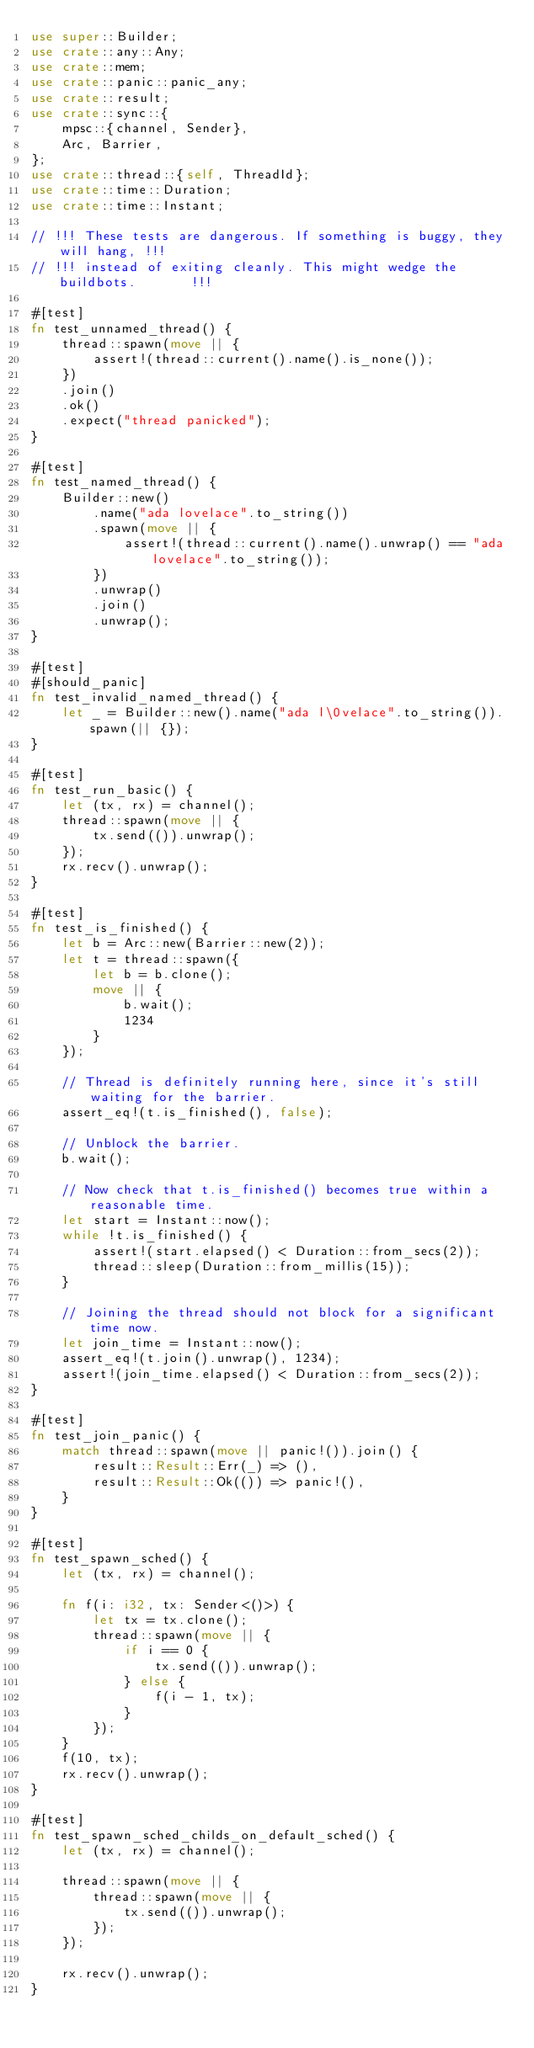Convert code to text. <code><loc_0><loc_0><loc_500><loc_500><_Rust_>use super::Builder;
use crate::any::Any;
use crate::mem;
use crate::panic::panic_any;
use crate::result;
use crate::sync::{
    mpsc::{channel, Sender},
    Arc, Barrier,
};
use crate::thread::{self, ThreadId};
use crate::time::Duration;
use crate::time::Instant;

// !!! These tests are dangerous. If something is buggy, they will hang, !!!
// !!! instead of exiting cleanly. This might wedge the buildbots.       !!!

#[test]
fn test_unnamed_thread() {
    thread::spawn(move || {
        assert!(thread::current().name().is_none());
    })
    .join()
    .ok()
    .expect("thread panicked");
}

#[test]
fn test_named_thread() {
    Builder::new()
        .name("ada lovelace".to_string())
        .spawn(move || {
            assert!(thread::current().name().unwrap() == "ada lovelace".to_string());
        })
        .unwrap()
        .join()
        .unwrap();
}

#[test]
#[should_panic]
fn test_invalid_named_thread() {
    let _ = Builder::new().name("ada l\0velace".to_string()).spawn(|| {});
}

#[test]
fn test_run_basic() {
    let (tx, rx) = channel();
    thread::spawn(move || {
        tx.send(()).unwrap();
    });
    rx.recv().unwrap();
}

#[test]
fn test_is_finished() {
    let b = Arc::new(Barrier::new(2));
    let t = thread::spawn({
        let b = b.clone();
        move || {
            b.wait();
            1234
        }
    });

    // Thread is definitely running here, since it's still waiting for the barrier.
    assert_eq!(t.is_finished(), false);

    // Unblock the barrier.
    b.wait();

    // Now check that t.is_finished() becomes true within a reasonable time.
    let start = Instant::now();
    while !t.is_finished() {
        assert!(start.elapsed() < Duration::from_secs(2));
        thread::sleep(Duration::from_millis(15));
    }

    // Joining the thread should not block for a significant time now.
    let join_time = Instant::now();
    assert_eq!(t.join().unwrap(), 1234);
    assert!(join_time.elapsed() < Duration::from_secs(2));
}

#[test]
fn test_join_panic() {
    match thread::spawn(move || panic!()).join() {
        result::Result::Err(_) => (),
        result::Result::Ok(()) => panic!(),
    }
}

#[test]
fn test_spawn_sched() {
    let (tx, rx) = channel();

    fn f(i: i32, tx: Sender<()>) {
        let tx = tx.clone();
        thread::spawn(move || {
            if i == 0 {
                tx.send(()).unwrap();
            } else {
                f(i - 1, tx);
            }
        });
    }
    f(10, tx);
    rx.recv().unwrap();
}

#[test]
fn test_spawn_sched_childs_on_default_sched() {
    let (tx, rx) = channel();

    thread::spawn(move || {
        thread::spawn(move || {
            tx.send(()).unwrap();
        });
    });

    rx.recv().unwrap();
}
</code> 